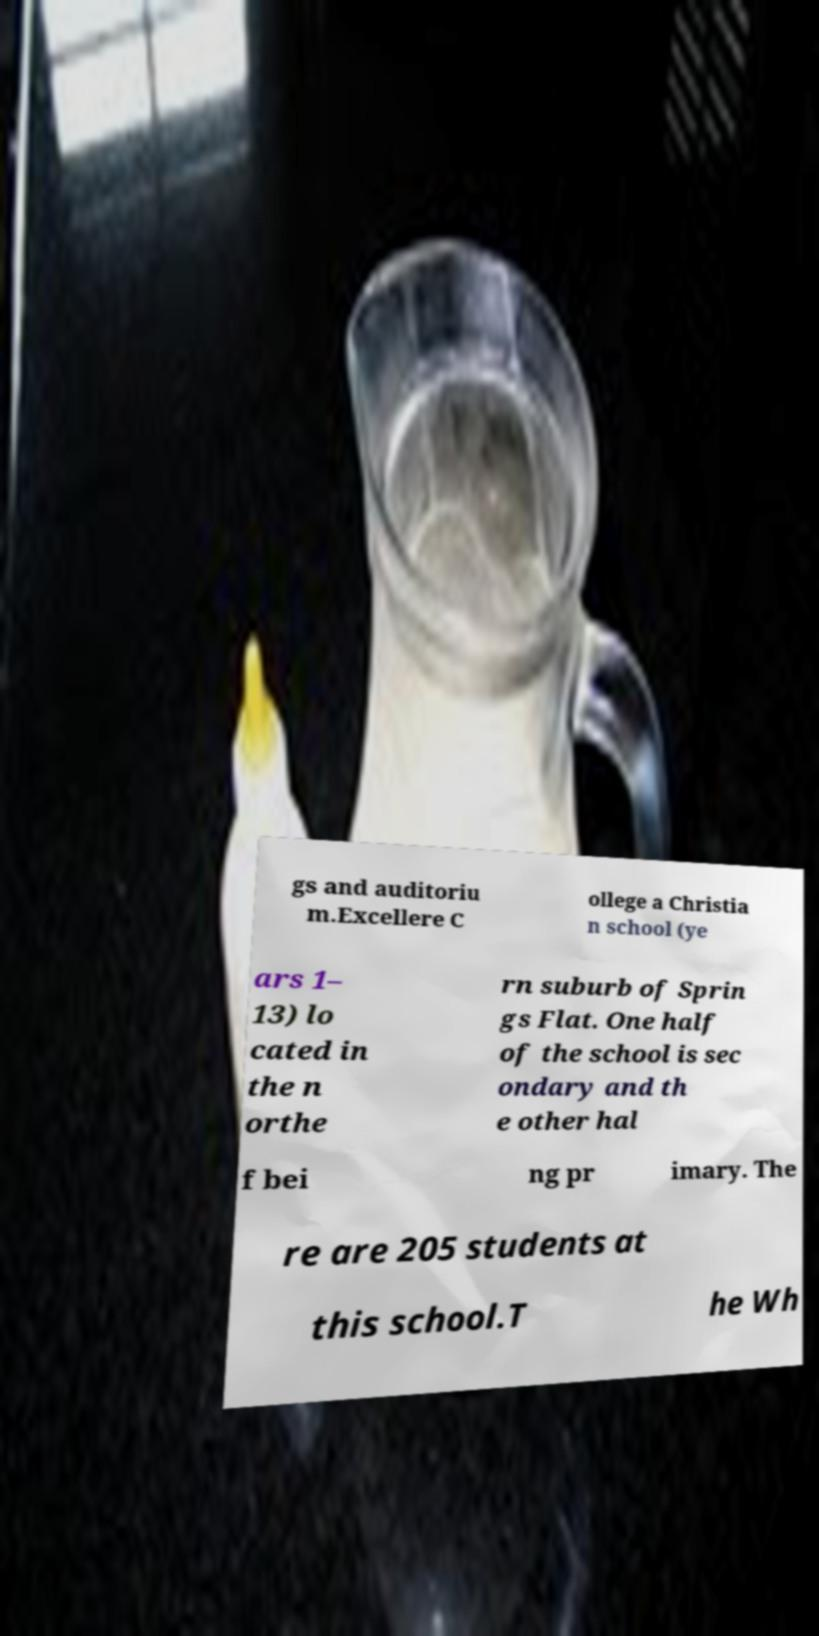I need the written content from this picture converted into text. Can you do that? gs and auditoriu m.Excellere C ollege a Christia n school (ye ars 1– 13) lo cated in the n orthe rn suburb of Sprin gs Flat. One half of the school is sec ondary and th e other hal f bei ng pr imary. The re are 205 students at this school.T he Wh 